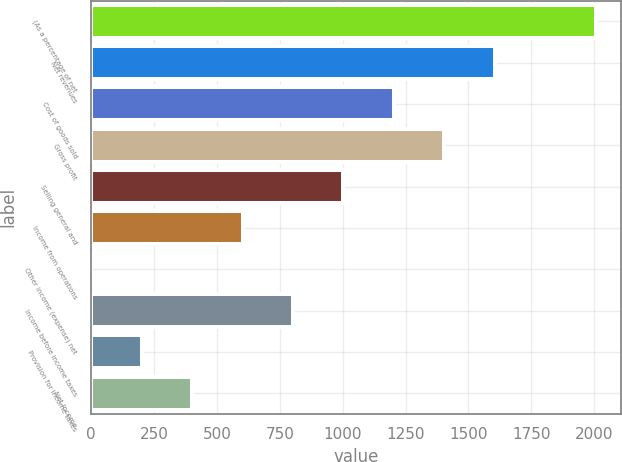Convert chart. <chart><loc_0><loc_0><loc_500><loc_500><bar_chart><fcel>(As a percentage of net<fcel>Net revenues<fcel>Cost of goods sold<fcel>Gross profit<fcel>Selling general and<fcel>Income from operations<fcel>Other income (expense) net<fcel>Income before income taxes<fcel>Provision for income taxes<fcel>Net income<nl><fcel>2006<fcel>1604.9<fcel>1203.8<fcel>1404.35<fcel>1003.25<fcel>602.15<fcel>0.5<fcel>802.7<fcel>201.05<fcel>401.6<nl></chart> 